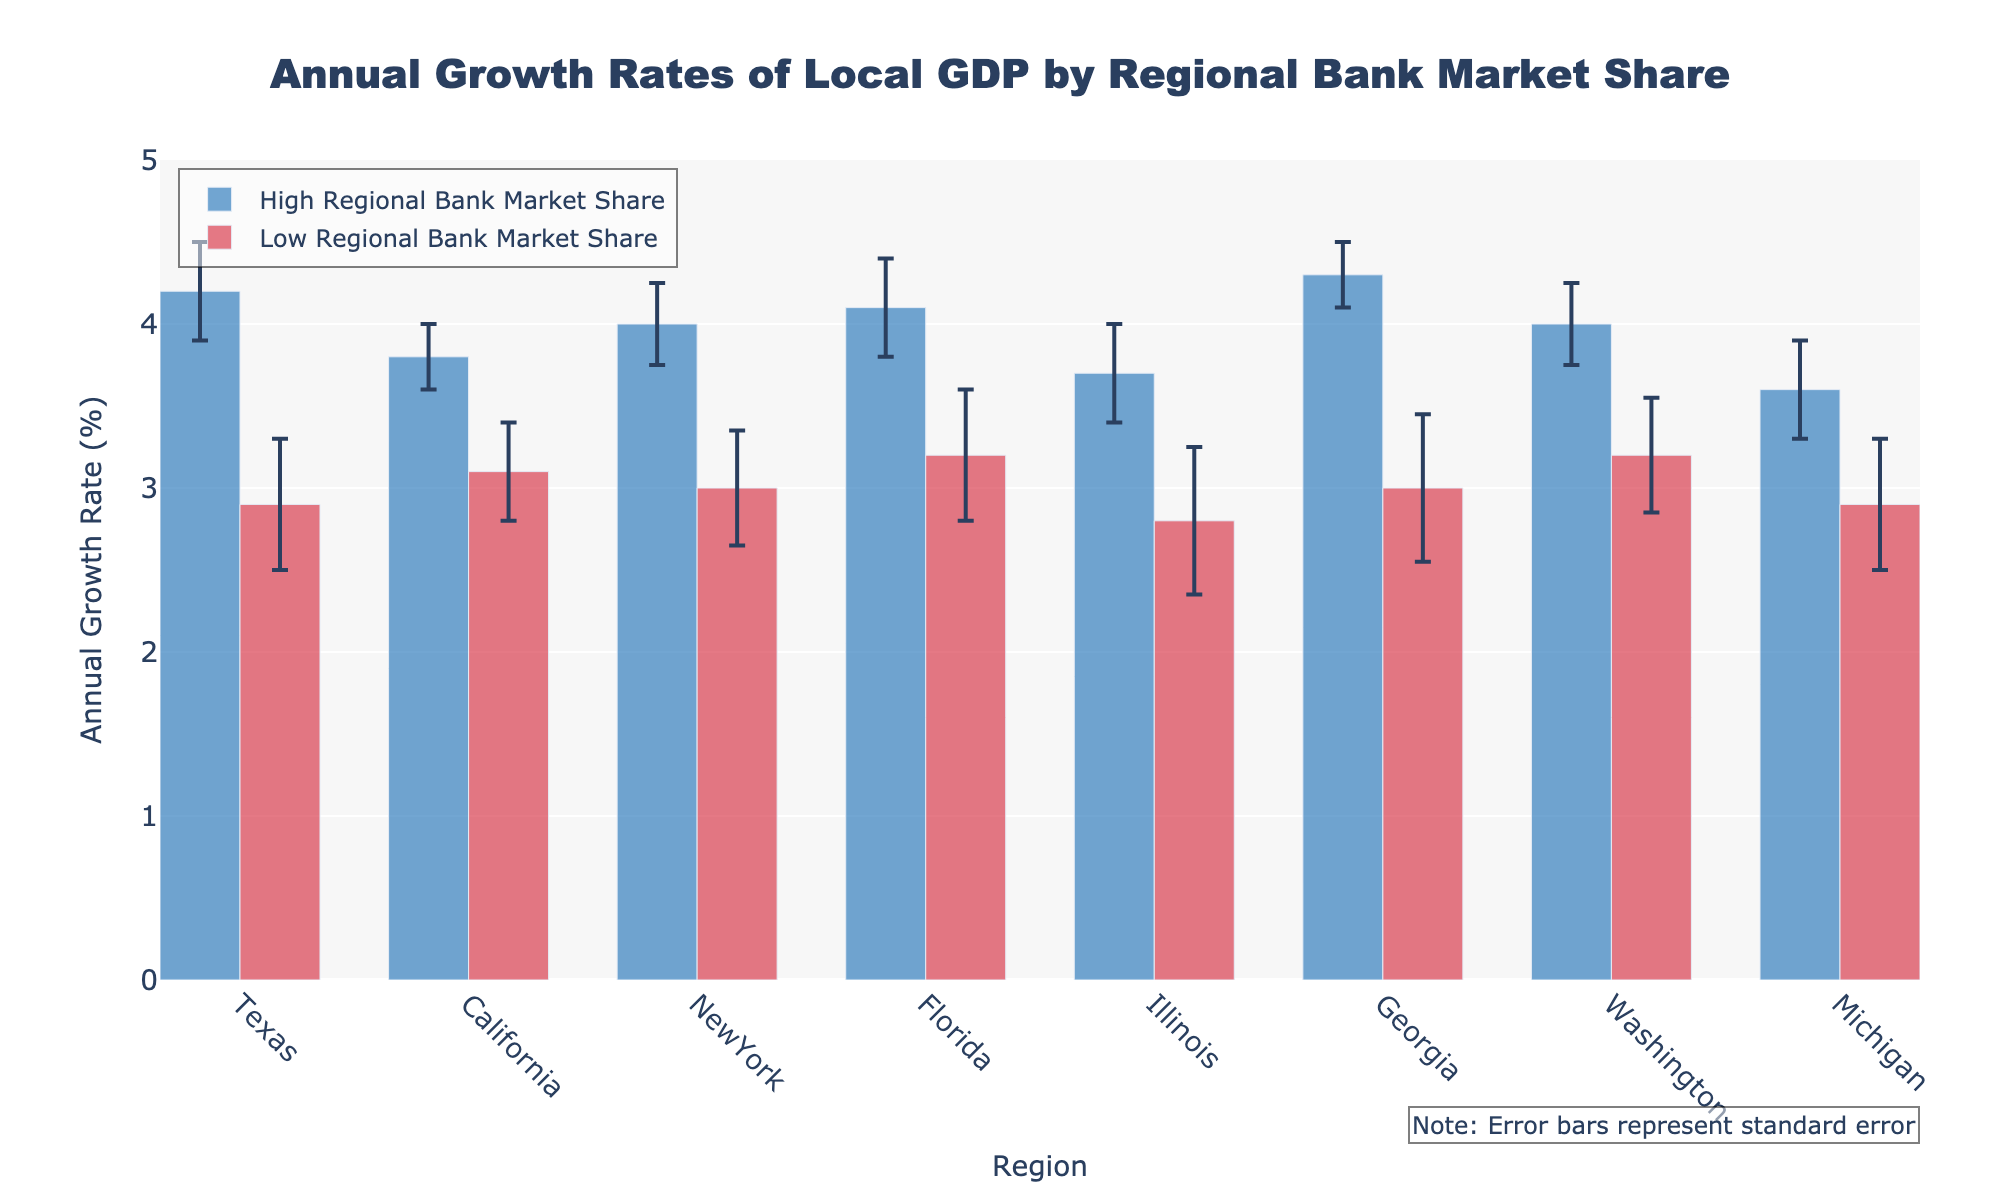What is the title of the plot? The title is typically found at the top of the figure. In this case, it is clearly stated.
Answer: "Annual Growth Rates of Local GDP by Regional Bank Market Share" Which region has the highest annual growth rate? By observing the height of the bars, we can identify that Georgia with high regional bank market share has the tallest bar, indicating the highest growth rate.
Answer: Georgia (High) What is the range of the y-axis? The y-axis, labeled as "Annual Growth Rate (%)," spans from its minimum to maximum value. By checking the axis' visual markings, we see the scale.
Answer: 0 to 5% How much higher is the growth rate in Texas with high market share compared to Texas with low market share? The growth rates are 4.2% for high market share and 2.9% for low market share. Subtract the lower value from the higher value to get the difference.
Answer: 1.3% What is the average annual growth rate for regions with low regional bank market share? Sum the growth rates for low market shares and divide by the number of these regions. (2.9 + 3.1 + 3.0 + 3.2 + 2.8 + 3.0 + 3.2 + 2.9) / 8 = 23.1 / 8
Answer: 2.89% Which region has the largest standard error for high regional bank market share? The standard errors are indicated by the error bars for high market shares. Illinois has the tallest error bar in the high market share group.
Answer: Illinois (High) Which pairs of regions have similar growth rates for high and low regional bank market shares? By visually comparing the heights of the paired bars, we observe California and Washington have close growth rates (3.8% vs 3.1%) and (4.0% vs 3.2%).
Answer: California and Washington Considering both high and low shares, what is the overall growth rate difference in New York? The growth rate for high is 4.0% and for low is 3.0%. Subtract the low rate from the high rate for New York.
Answer: 1.0% How does the annual growth rate in Michigan with high market share compare to California with low market share? Compare the bar heights for the specified regions. Michigan (High) is 3.6% and California (Low) is 3.1%.
Answer: Michigan (High) is higher by 0.5% What visual feature represents the uncertainty in the data for each region? The error bars extending from the tops of the bars indicate the standard errors, representing the uncertainty.
Answer: Error bars 